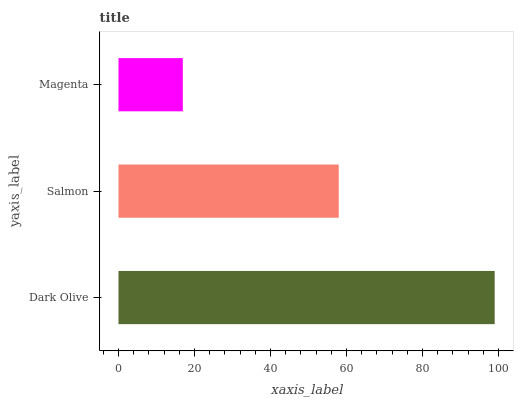Is Magenta the minimum?
Answer yes or no. Yes. Is Dark Olive the maximum?
Answer yes or no. Yes. Is Salmon the minimum?
Answer yes or no. No. Is Salmon the maximum?
Answer yes or no. No. Is Dark Olive greater than Salmon?
Answer yes or no. Yes. Is Salmon less than Dark Olive?
Answer yes or no. Yes. Is Salmon greater than Dark Olive?
Answer yes or no. No. Is Dark Olive less than Salmon?
Answer yes or no. No. Is Salmon the high median?
Answer yes or no. Yes. Is Salmon the low median?
Answer yes or no. Yes. Is Magenta the high median?
Answer yes or no. No. Is Dark Olive the low median?
Answer yes or no. No. 